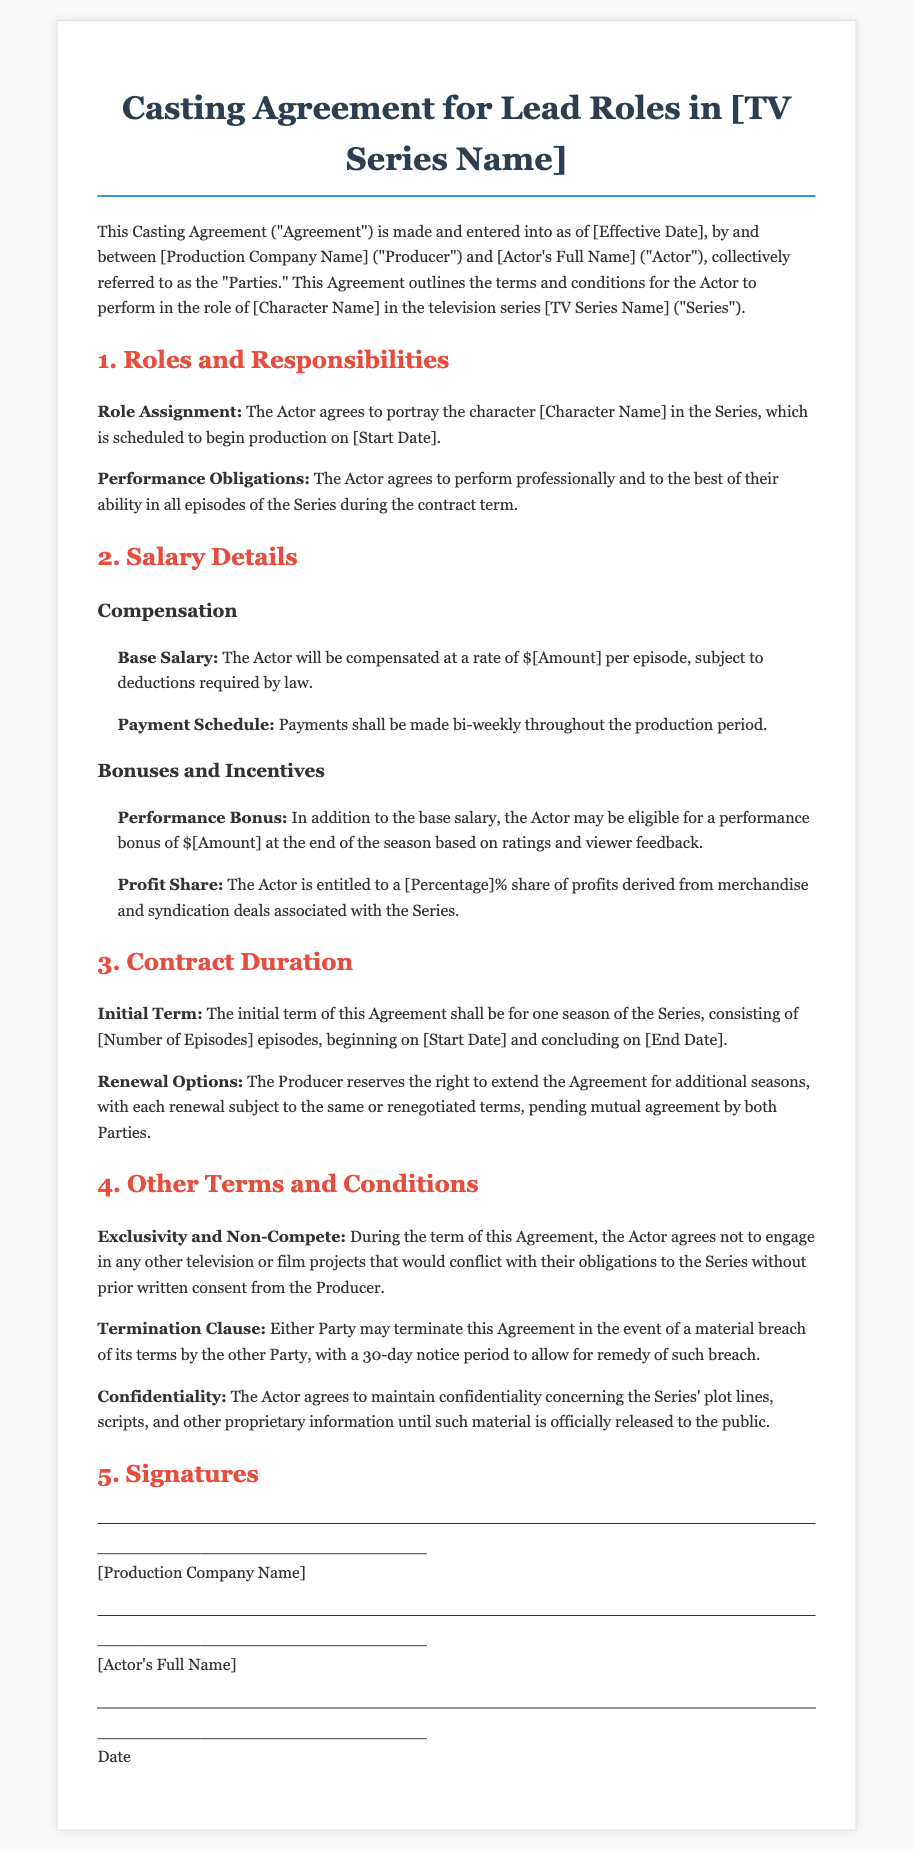What is the effective date of the agreement? The document states the effective date is represented as [Effective Date], a placeholder for the actual date.
Answer: [Effective Date] What is the actor's role in the series? The agreement specifies that the actor will portray the character [Character Name], serving as a placeholder for the actual character name.
Answer: [Character Name] What is the base salary per episode? The document indicates the base salary is represented by the placeholder [Amount].
Answer: [Amount] What is the initial term of the agreement? The contract specifies the initial term consists of one season and mentions [Number of Episodes] as a placeholder for the actual number of episodes.
Answer: one season of [Number of Episodes] episodes How often will payments be made during production? The document outlines that payments are to be made bi-weekly throughout the production period.
Answer: bi-weekly What percentage of profit share is the actor entitled to? The agreement contains a placeholder for the profit share percentage as [Percentage]%.
Answer: [Percentage]% What is the notice period for termination due to a material breach? The document specifies a 30-day notice period for allowing remedy of a material breach.
Answer: 30-day Is the actor allowed to engage in other projects during the contract term? The agreement states that the actor must not engage in other conflicting projects without written consent.
Answer: No What happens to the agreement if the producer wants to extend it? The document mentions that the producer reserves the right to extend the agreement for additional seasons, which is subject to mutual agreement.
Answer: Renewal options 